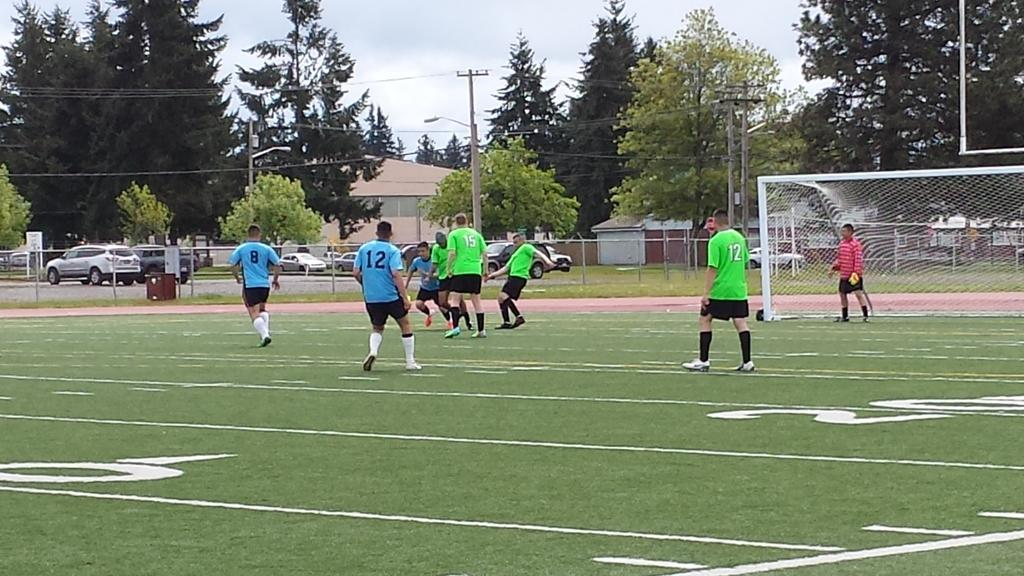Provide a one-sentence caption for the provided image. soccer players on a field with one wearing the number 12 jersey. 